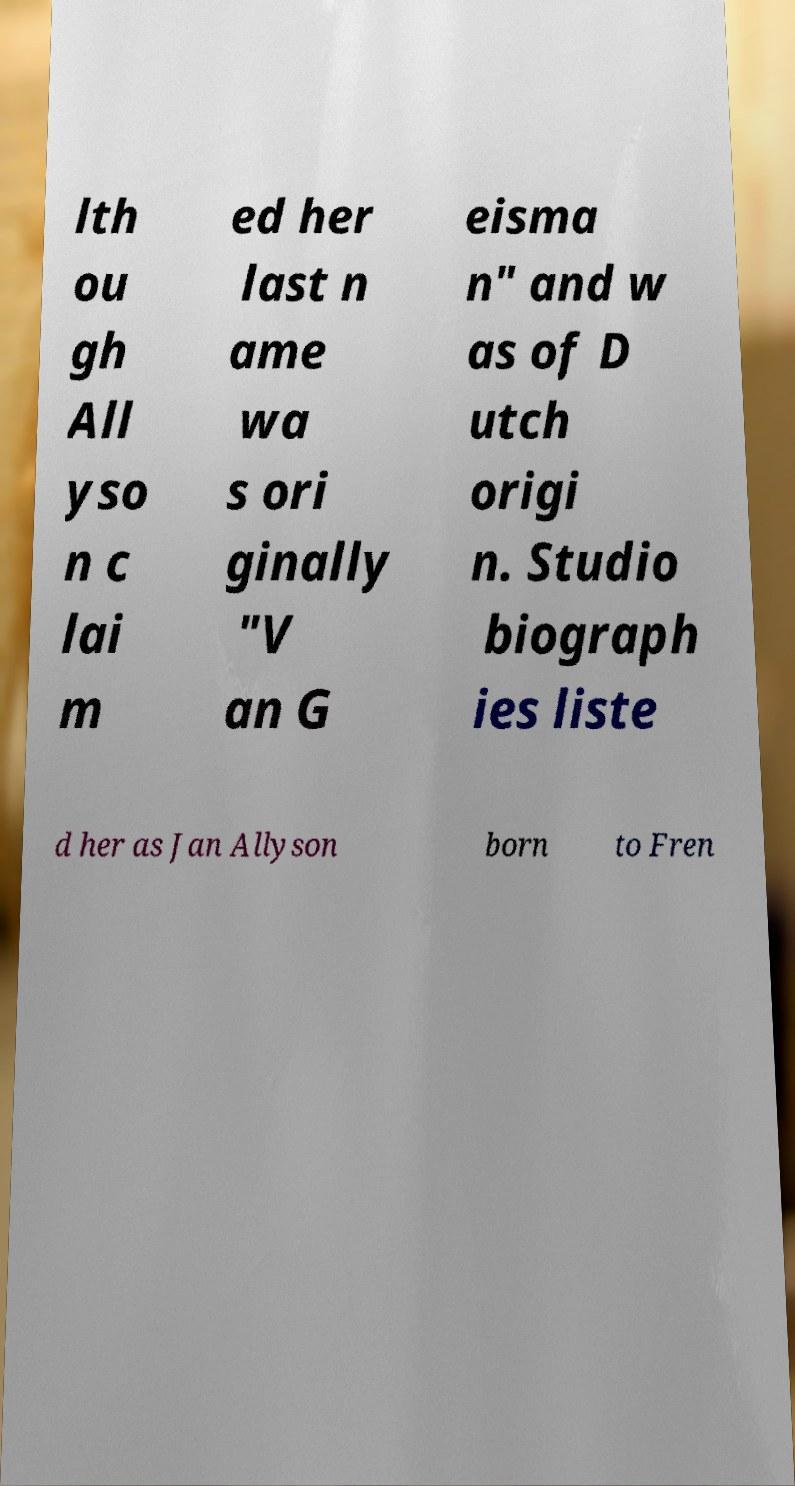Could you extract and type out the text from this image? lth ou gh All yso n c lai m ed her last n ame wa s ori ginally "V an G eisma n" and w as of D utch origi n. Studio biograph ies liste d her as Jan Allyson born to Fren 